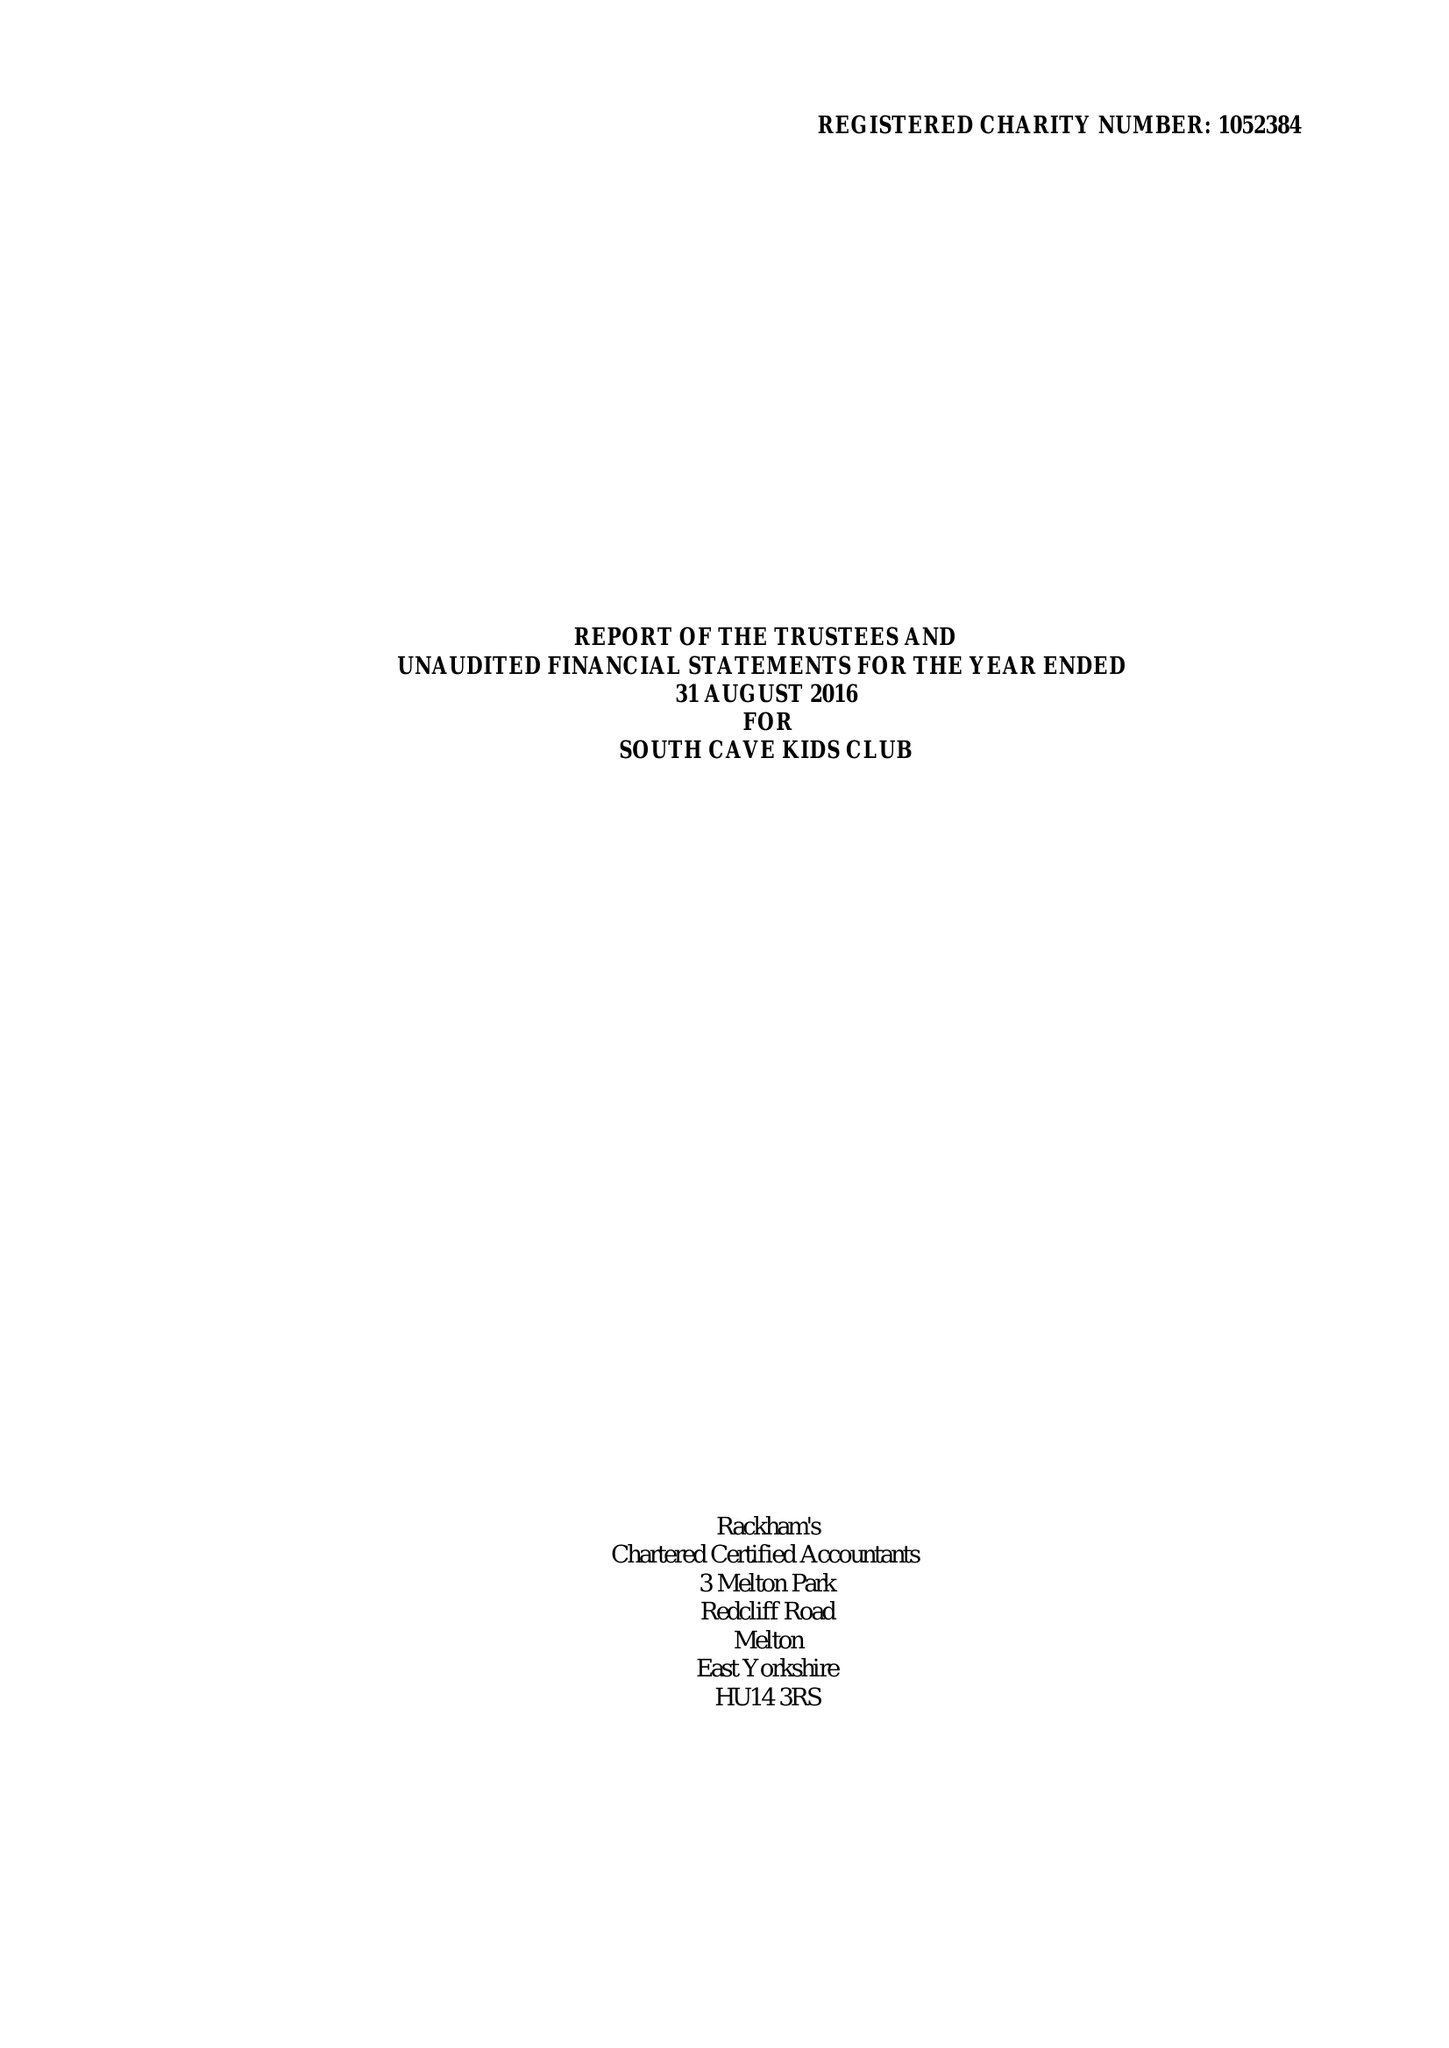What is the value for the spending_annually_in_british_pounds?
Answer the question using a single word or phrase. 121995.00 